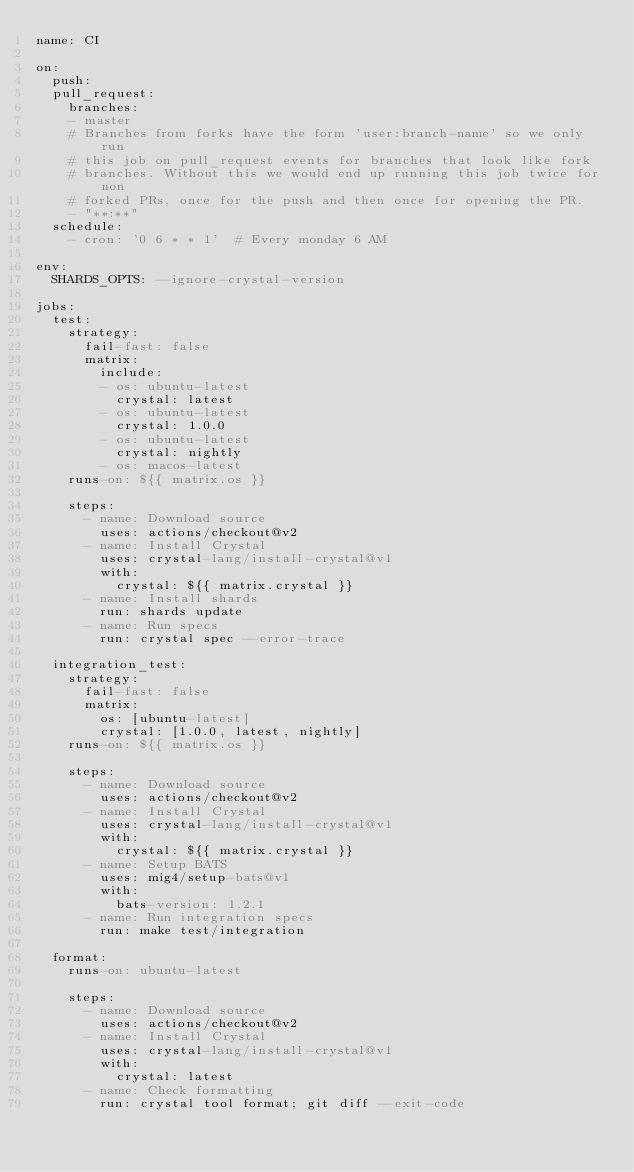Convert code to text. <code><loc_0><loc_0><loc_500><loc_500><_YAML_>name: CI

on:
  push:
  pull_request:
    branches:
    - master
    # Branches from forks have the form 'user:branch-name' so we only run
    # this job on pull_request events for branches that look like fork
    # branches. Without this we would end up running this job twice for non
    # forked PRs, once for the push and then once for opening the PR.
    - "**:**"
  schedule:
    - cron: '0 6 * * 1'  # Every monday 6 AM

env:
  SHARDS_OPTS: --ignore-crystal-version

jobs:
  test:
    strategy:
      fail-fast: false
      matrix:
        include:
        - os: ubuntu-latest
          crystal: latest
        - os: ubuntu-latest
          crystal: 1.0.0
        - os: ubuntu-latest
          crystal: nightly
        - os: macos-latest
    runs-on: ${{ matrix.os }}

    steps:
      - name: Download source
        uses: actions/checkout@v2
      - name: Install Crystal
        uses: crystal-lang/install-crystal@v1
        with:
          crystal: ${{ matrix.crystal }}
      - name: Install shards
        run: shards update
      - name: Run specs
        run: crystal spec --error-trace

  integration_test:
    strategy:
      fail-fast: false
      matrix:
        os: [ubuntu-latest]
        crystal: [1.0.0, latest, nightly]
    runs-on: ${{ matrix.os }}

    steps:
      - name: Download source
        uses: actions/checkout@v2
      - name: Install Crystal
        uses: crystal-lang/install-crystal@v1
        with:
          crystal: ${{ matrix.crystal }}
      - name: Setup BATS
        uses: mig4/setup-bats@v1
        with:
          bats-version: 1.2.1
      - name: Run integration specs
        run: make test/integration

  format:
    runs-on: ubuntu-latest

    steps:
      - name: Download source
        uses: actions/checkout@v2
      - name: Install Crystal
        uses: crystal-lang/install-crystal@v1
        with:
          crystal: latest
      - name: Check formatting
        run: crystal tool format; git diff --exit-code
</code> 